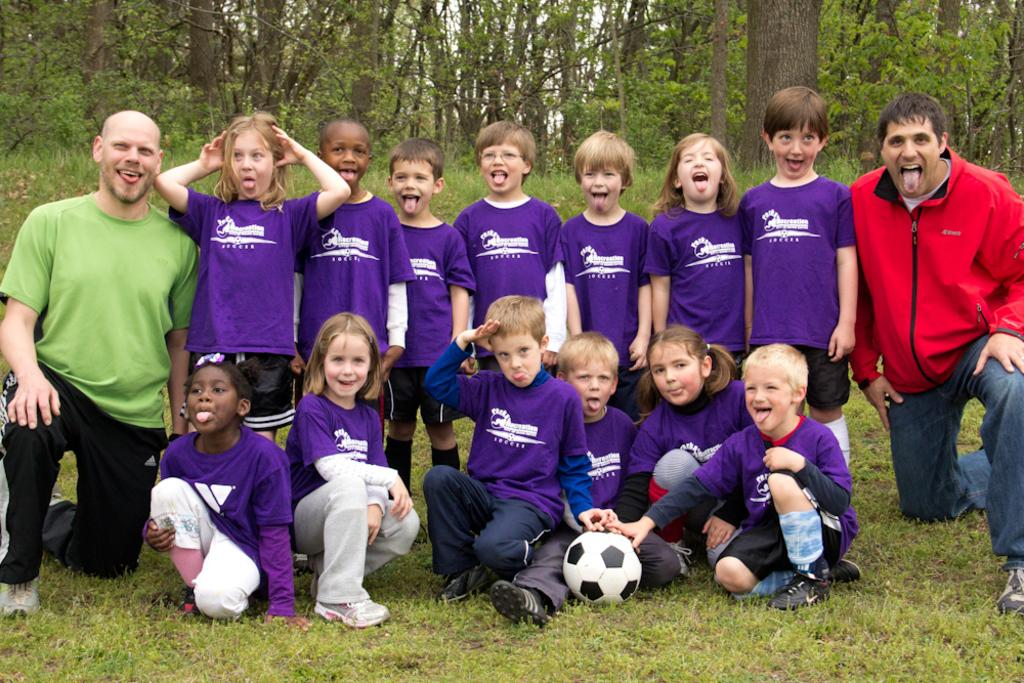How many kids are in the picture? There are kids in the picture, but the exact number is not specified. What are the kids doing in the picture? Some kids are standing, while others are sitting on the grass floor. Are there any adults present in the picture? Yes, there are two men on either side of the kids. What type of wristwatch is the authority figure wearing in the image? There is no mention of an authority figure or a wristwatch in the image, so it is not possible to answer that question. 